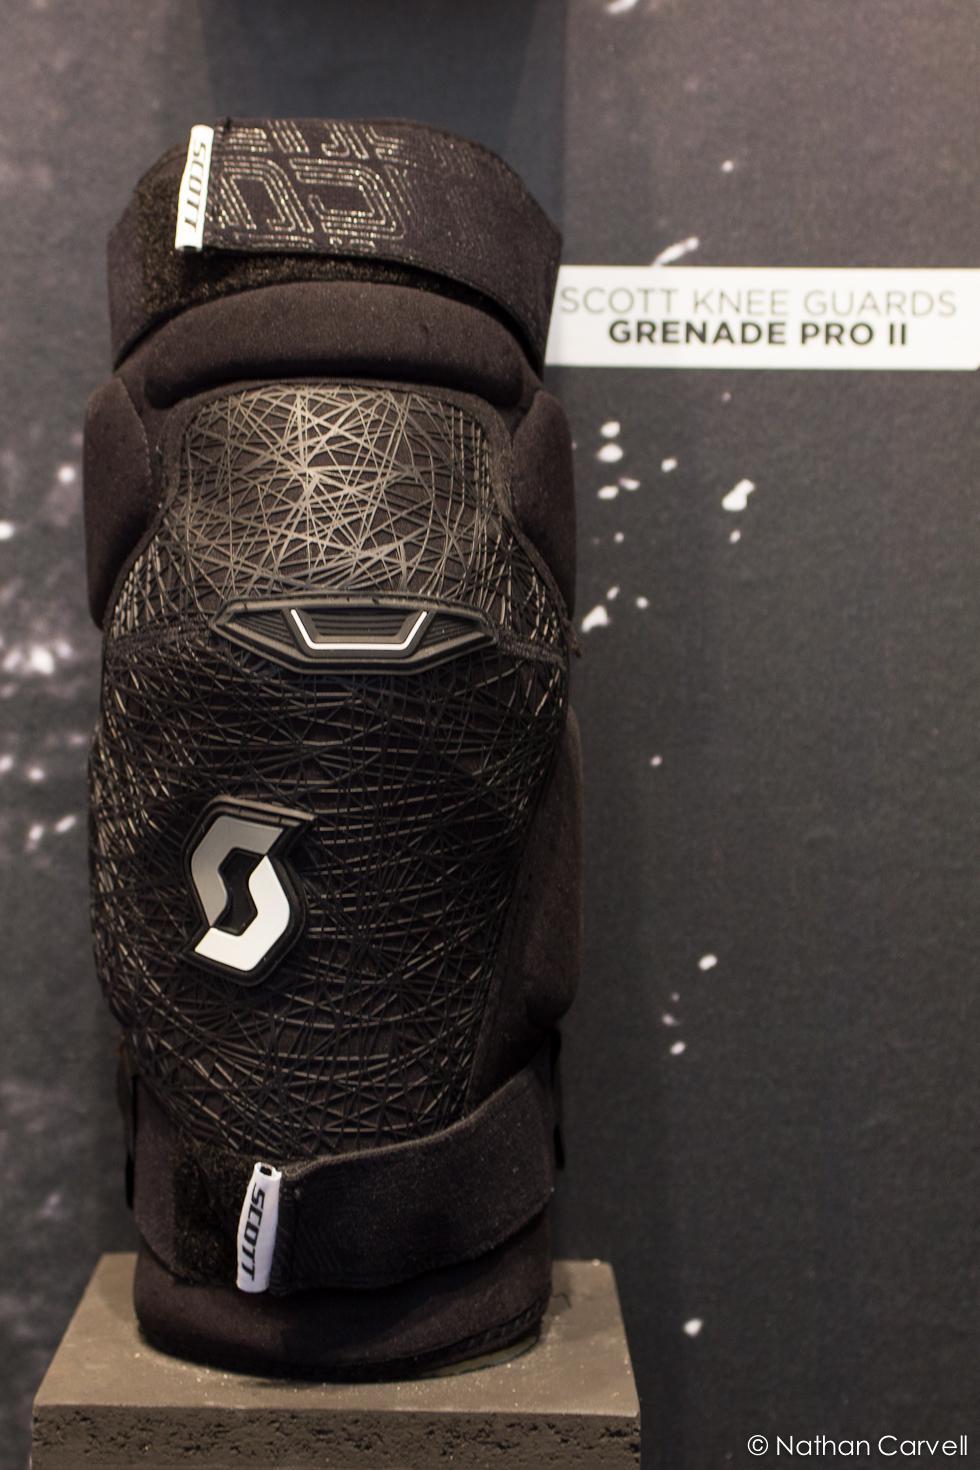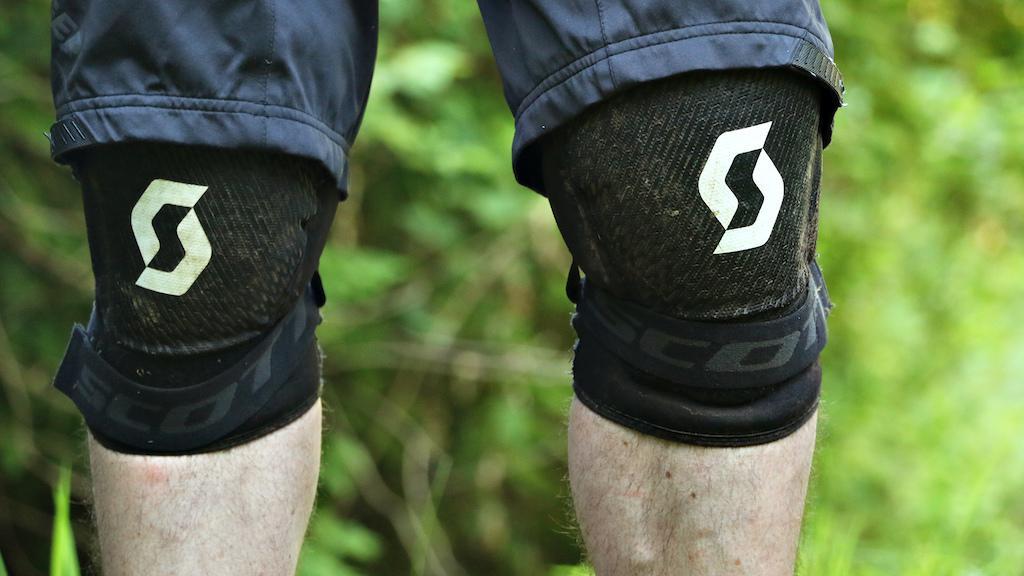The first image is the image on the left, the second image is the image on the right. Evaluate the accuracy of this statement regarding the images: "The left image features an unworn black knee pad, while the right image shows a pair of human legs wearing a pair of black knee pads.". Is it true? Answer yes or no. Yes. The first image is the image on the left, the second image is the image on the right. For the images shown, is this caption "The knee guards are being worn by a person in one of the images." true? Answer yes or no. Yes. 